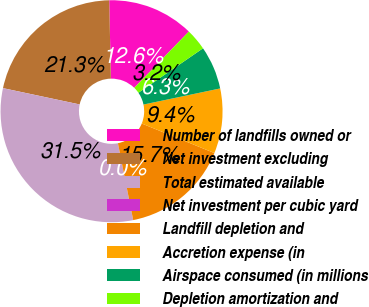<chart> <loc_0><loc_0><loc_500><loc_500><pie_chart><fcel>Number of landfills owned or<fcel>Net investment excluding<fcel>Total estimated available<fcel>Net investment per cubic yard<fcel>Landfill depletion and<fcel>Accretion expense (in<fcel>Airspace consumed (in millions<fcel>Depletion amortization and<nl><fcel>12.59%<fcel>21.33%<fcel>31.46%<fcel>0.0%<fcel>15.73%<fcel>9.44%<fcel>6.3%<fcel>3.15%<nl></chart> 